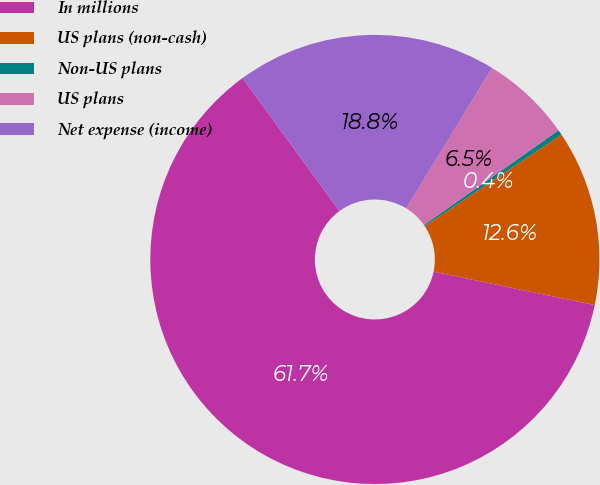<chart> <loc_0><loc_0><loc_500><loc_500><pie_chart><fcel>In millions<fcel>US plans (non-cash)<fcel>Non-US plans<fcel>US plans<fcel>Net expense (income)<nl><fcel>61.71%<fcel>12.64%<fcel>0.37%<fcel>6.5%<fcel>18.77%<nl></chart> 